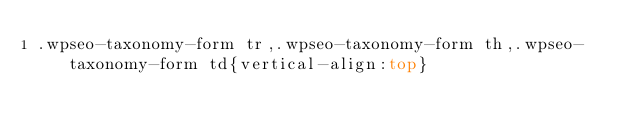Convert code to text. <code><loc_0><loc_0><loc_500><loc_500><_CSS_>.wpseo-taxonomy-form tr,.wpseo-taxonomy-form th,.wpseo-taxonomy-form td{vertical-align:top}</code> 